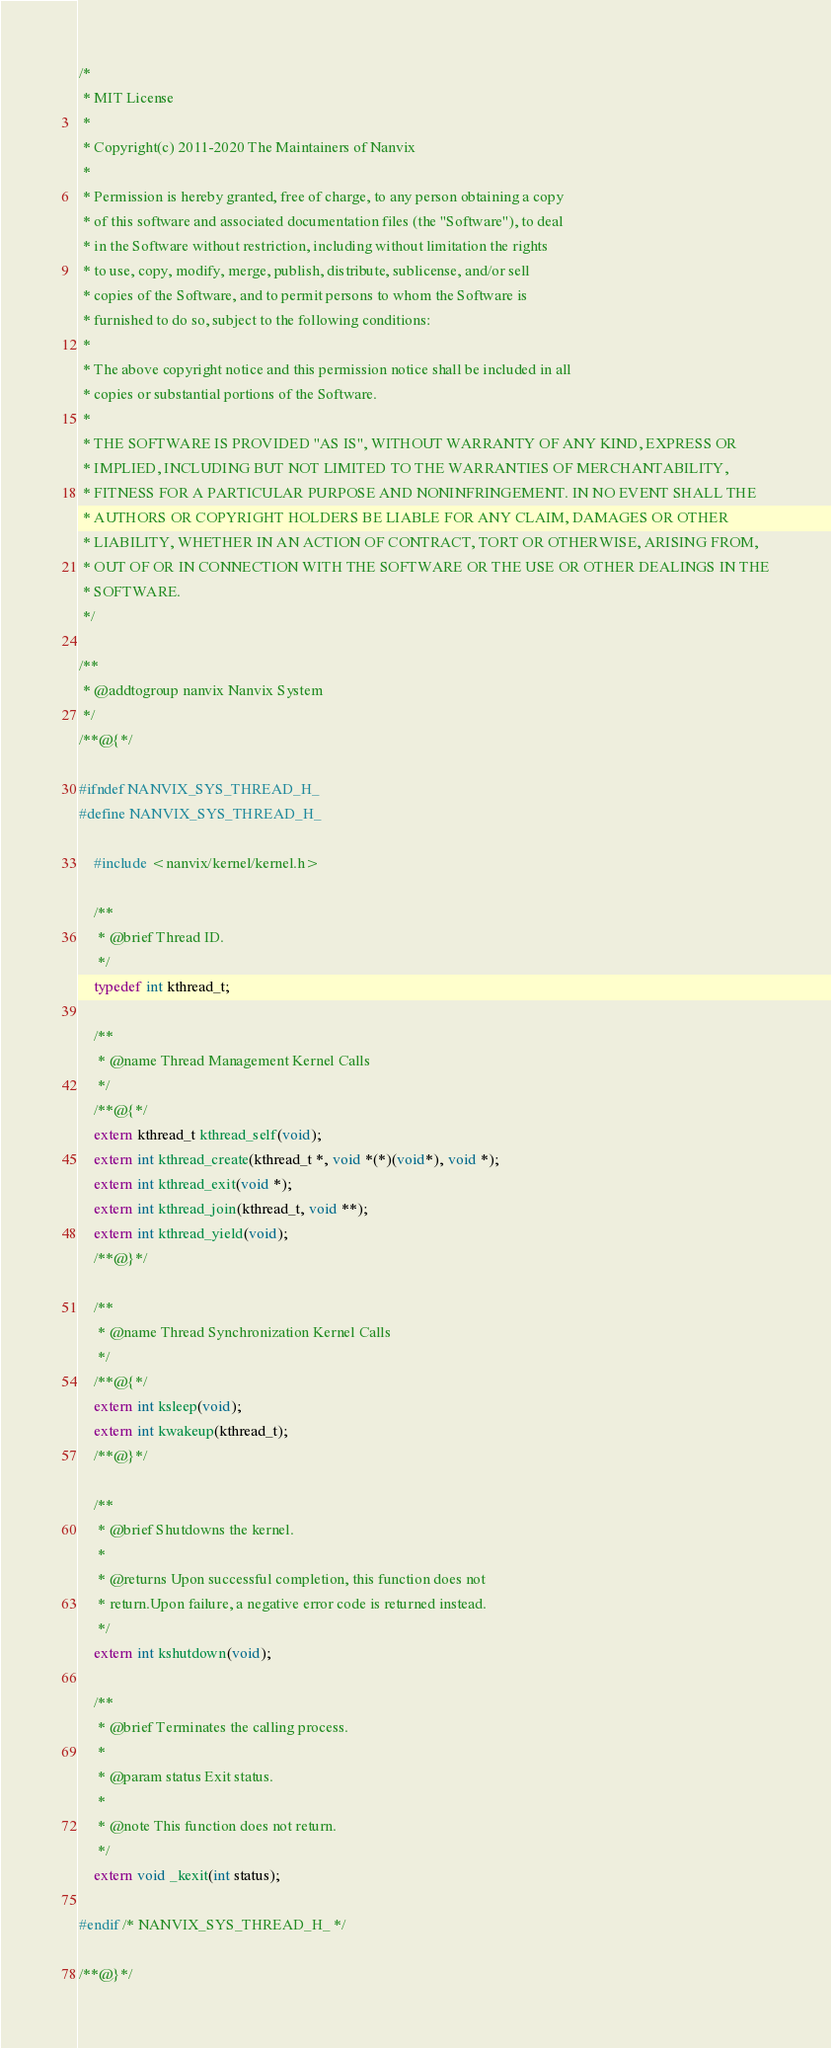<code> <loc_0><loc_0><loc_500><loc_500><_C_>/*
 * MIT License
 *
 * Copyright(c) 2011-2020 The Maintainers of Nanvix
 *
 * Permission is hereby granted, free of charge, to any person obtaining a copy
 * of this software and associated documentation files (the "Software"), to deal
 * in the Software without restriction, including without limitation the rights
 * to use, copy, modify, merge, publish, distribute, sublicense, and/or sell
 * copies of the Software, and to permit persons to whom the Software is
 * furnished to do so, subject to the following conditions:
 *
 * The above copyright notice and this permission notice shall be included in all
 * copies or substantial portions of the Software.
 *
 * THE SOFTWARE IS PROVIDED "AS IS", WITHOUT WARRANTY OF ANY KIND, EXPRESS OR
 * IMPLIED, INCLUDING BUT NOT LIMITED TO THE WARRANTIES OF MERCHANTABILITY,
 * FITNESS FOR A PARTICULAR PURPOSE AND NONINFRINGEMENT. IN NO EVENT SHALL THE
 * AUTHORS OR COPYRIGHT HOLDERS BE LIABLE FOR ANY CLAIM, DAMAGES OR OTHER
 * LIABILITY, WHETHER IN AN ACTION OF CONTRACT, TORT OR OTHERWISE, ARISING FROM,
 * OUT OF OR IN CONNECTION WITH THE SOFTWARE OR THE USE OR OTHER DEALINGS IN THE
 * SOFTWARE.
 */

/**
 * @addtogroup nanvix Nanvix System
 */
/**@{*/

#ifndef NANVIX_SYS_THREAD_H_
#define NANVIX_SYS_THREAD_H_

	#include <nanvix/kernel/kernel.h>

	/**
	 * @brief Thread ID.
	 */
	typedef int kthread_t;

	/**
	 * @name Thread Management Kernel Calls
	 */
	/**@{*/
	extern kthread_t kthread_self(void);
	extern int kthread_create(kthread_t *, void *(*)(void*), void *);
	extern int kthread_exit(void *);
	extern int kthread_join(kthread_t, void **);
	extern int kthread_yield(void);
	/**@}*/

	/**
	 * @name Thread Synchronization Kernel Calls
	 */
	/**@{*/
	extern int ksleep(void);
	extern int kwakeup(kthread_t);
	/**@}*/

	/**
	 * @brief Shutdowns the kernel.
	 *
	 * @returns Upon successful completion, this function does not
	 * return.Upon failure, a negative error code is returned instead.
	 */
	extern int kshutdown(void);

	/**
	 * @brief Terminates the calling process.
	 *
	 * @param status Exit status.
	 *
	 * @note This function does not return.
	 */
	extern void _kexit(int status);

#endif /* NANVIX_SYS_THREAD_H_ */

/**@}*/
</code> 